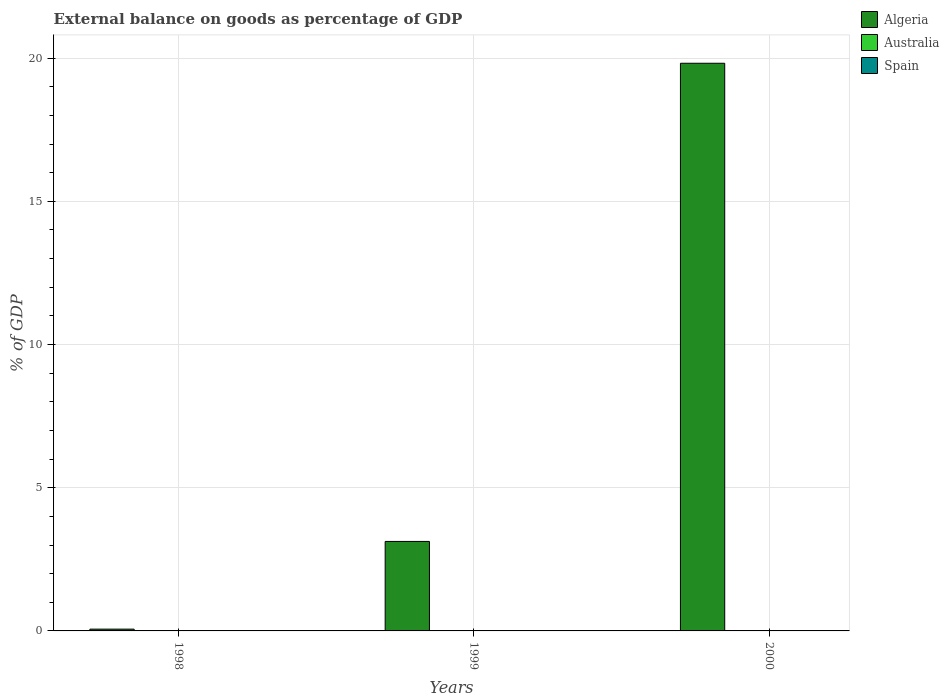How many different coloured bars are there?
Keep it short and to the point. 1. Are the number of bars per tick equal to the number of legend labels?
Your response must be concise. No. Are the number of bars on each tick of the X-axis equal?
Keep it short and to the point. Yes. How many bars are there on the 3rd tick from the left?
Your response must be concise. 1. How many bars are there on the 1st tick from the right?
Ensure brevity in your answer.  1. What is the label of the 1st group of bars from the left?
Your answer should be very brief. 1998. What is the external balance on goods as percentage of GDP in Algeria in 1998?
Provide a succinct answer. 0.06. Across all years, what is the maximum external balance on goods as percentage of GDP in Algeria?
Ensure brevity in your answer.  19.82. In which year was the external balance on goods as percentage of GDP in Algeria maximum?
Your response must be concise. 2000. What is the total external balance on goods as percentage of GDP in Australia in the graph?
Provide a succinct answer. 0. What is the difference between the external balance on goods as percentage of GDP in Algeria in 1998 and that in 1999?
Your response must be concise. -3.06. What is the difference between the external balance on goods as percentage of GDP in Spain in 1998 and the external balance on goods as percentage of GDP in Australia in 1999?
Ensure brevity in your answer.  0. What is the average external balance on goods as percentage of GDP in Australia per year?
Provide a succinct answer. 0. In how many years, is the external balance on goods as percentage of GDP in Spain greater than 13 %?
Provide a short and direct response. 0. What is the ratio of the external balance on goods as percentage of GDP in Algeria in 1998 to that in 2000?
Ensure brevity in your answer.  0. What is the difference between the highest and the second highest external balance on goods as percentage of GDP in Algeria?
Offer a terse response. 16.7. What is the difference between the highest and the lowest external balance on goods as percentage of GDP in Algeria?
Your response must be concise. 19.76. Is it the case that in every year, the sum of the external balance on goods as percentage of GDP in Algeria and external balance on goods as percentage of GDP in Australia is greater than the external balance on goods as percentage of GDP in Spain?
Keep it short and to the point. Yes. How many bars are there?
Offer a terse response. 3. How many years are there in the graph?
Offer a very short reply. 3. Are the values on the major ticks of Y-axis written in scientific E-notation?
Your answer should be compact. No. What is the title of the graph?
Your answer should be very brief. External balance on goods as percentage of GDP. Does "Belize" appear as one of the legend labels in the graph?
Keep it short and to the point. No. What is the label or title of the X-axis?
Provide a short and direct response. Years. What is the label or title of the Y-axis?
Your answer should be compact. % of GDP. What is the % of GDP in Algeria in 1998?
Make the answer very short. 0.06. What is the % of GDP of Spain in 1998?
Your answer should be compact. 0. What is the % of GDP of Algeria in 1999?
Ensure brevity in your answer.  3.12. What is the % of GDP of Spain in 1999?
Your answer should be very brief. 0. What is the % of GDP of Algeria in 2000?
Your answer should be very brief. 19.82. What is the % of GDP of Australia in 2000?
Your answer should be compact. 0. What is the % of GDP in Spain in 2000?
Offer a terse response. 0. Across all years, what is the maximum % of GDP in Algeria?
Give a very brief answer. 19.82. Across all years, what is the minimum % of GDP in Algeria?
Make the answer very short. 0.06. What is the total % of GDP of Algeria in the graph?
Keep it short and to the point. 23.01. What is the total % of GDP of Spain in the graph?
Your response must be concise. 0. What is the difference between the % of GDP in Algeria in 1998 and that in 1999?
Keep it short and to the point. -3.06. What is the difference between the % of GDP in Algeria in 1998 and that in 2000?
Ensure brevity in your answer.  -19.76. What is the difference between the % of GDP in Algeria in 1999 and that in 2000?
Give a very brief answer. -16.7. What is the average % of GDP of Algeria per year?
Provide a succinct answer. 7.67. What is the average % of GDP in Australia per year?
Provide a short and direct response. 0. What is the average % of GDP in Spain per year?
Give a very brief answer. 0. What is the ratio of the % of GDP in Algeria in 1998 to that in 1999?
Offer a very short reply. 0.02. What is the ratio of the % of GDP in Algeria in 1998 to that in 2000?
Your answer should be very brief. 0. What is the ratio of the % of GDP of Algeria in 1999 to that in 2000?
Offer a very short reply. 0.16. What is the difference between the highest and the second highest % of GDP of Algeria?
Give a very brief answer. 16.7. What is the difference between the highest and the lowest % of GDP of Algeria?
Your answer should be compact. 19.76. 